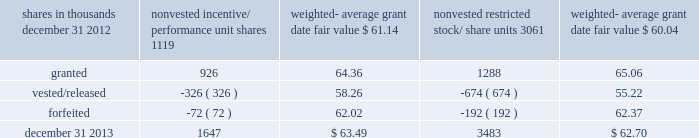To determine stock-based compensation expense , the grant date fair value is applied to the options granted with a reduction for estimated forfeitures .
We recognize compensation expense for stock options on a straight-line basis over the specified vesting period .
At december 31 , 2012 and 2011 , options for 12759000 and 12337000 shares of common stock were exercisable at a weighted-average price of $ 90.86 and $ 106.08 , respectively .
The total intrinsic value of options exercised during 2013 , 2012 and 2011 was $ 86 million , $ 37 million and $ 4 million , respectively .
The total tax benefit recognized related to compensation expense on all share-based payment arrangements during 2013 , 2012 and 2011 was approximately $ 56 million , $ 37 million and $ 38 million , respectively .
Cash received from option exercises under all incentive plans for 2013 , 2012 and 2011 was approximately $ 208 million , $ 118 million and $ 41 million , respectively .
The tax benefit realized from option exercises under all incentive plans for 2013 , 2012 and 2011 was approximately $ 31 million , $ 14 million and $ 1 million , respectively .
Shares of common stock available during the next year for the granting of options and other awards under the incentive plans were 24535159 at december 31 , 2013 .
Total shares of pnc common stock authorized for future issuance under equity compensation plans totaled 25712719 shares at december 31 , 2013 , which includes shares available for issuance under the incentive plans and the employee stock purchase plan ( espp ) as described below .
During 2013 , we issued approximately 2.6 million shares from treasury stock in connection with stock option exercise activity .
As with past exercise activity , we currently intend to utilize primarily treasury stock for any future stock option exercises .
Awards granted to non-employee directors in 2013 , 2012 and 2011 include 27076 , 25620 and 27090 deferred stock units , respectively , awarded under the outside directors deferred stock unit plan .
A deferred stock unit is a phantom share of our common stock , which is accounted for as a liability until such awards are paid to the participants in cash .
As there are no vesting or service requirements on these awards , total compensation expense is recognized in full for these awards on the date of grant .
Incentive/performance unit share awards and restricted stock/share unit awards the fair value of nonvested incentive/performance unit share awards and restricted stock/share unit awards is initially determined based on prices not less than the market value of our common stock on the date of grant .
The value of certain incentive/performance unit share awards is subsequently remeasured based on the achievement of one or more financial and other performance goals , generally over a three-year period .
The personnel and compensation committee ( 201cp&cc 201d ) of the board of directors approves the final award payout with respect to certain incentive/performance unit share awards .
Restricted stock/share unit awards have various vesting periods generally ranging from 3 years to 5 years .
Beginning in 2013 , we incorporated several enhanced risk- related performance changes to certain long-term incentive compensation programs .
In addition to achieving certain financial performance metrics on both an absolute basis and relative to our peers , final payout amounts will be subject to reduction if pnc fails to meet certain risk-related performance metrics as specified in the award agreement .
However , the p&cc has the discretion to waive any or all of this reduction under certain circumstances .
These awards have either a three- year or a four-year performance period and are payable in either stock or a combination of stock and cash .
Additionally , performance-based restricted share units were granted in 2013 to certain executives as part of annual bonus deferral criteria .
These units , payable solely in stock , vest ratably over a four-year period and contain the same risk- related discretionary criteria noted in the preceding paragraph .
The weighted-average grant date fair value of incentive/ performance unit share awards and restricted stock/unit awards granted in 2013 , 2012 and 2011 was $ 64.77 , $ 60.68 and $ 63.25 per share , respectively .
The total fair value of incentive/performance unit share and restricted stock/unit awards vested during 2013 , 2012 and 2011 was approximately $ 63 million , $ 55 million and $ 52 million , respectively .
We recognize compensation expense for such awards ratably over the corresponding vesting and/or performance periods for each type of program .
Table 124 : nonvested incentive/performance unit share awards and restricted stock/share unit awards 2013 rollforward shares in thousands nonvested incentive/ performance unit shares weighted- average grant date fair value nonvested restricted stock/ weighted- average grant date fair value .
The pnc financial services group , inc .
2013 form 10-k 187 .
What was the total fair value of incentive/performance unit share and restricted stock/unit awards vested during 2013 and 2012 in millions? 
Computations: (63 + 55)
Answer: 118.0. 